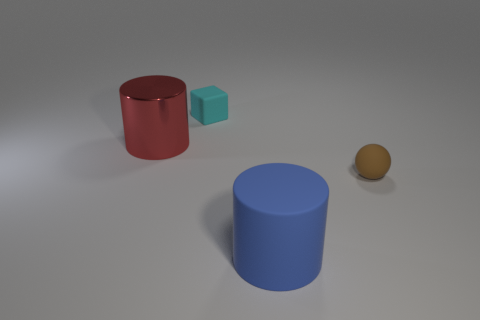What number of blue cylinders are the same size as the red cylinder?
Offer a terse response. 1. What is the shape of the big object that is in front of the large thing that is behind the large rubber cylinder?
Your answer should be very brief. Cylinder. Are there fewer big metal cylinders than tiny objects?
Offer a very short reply. Yes. What color is the small thing that is in front of the red object?
Offer a terse response. Brown. There is a thing that is both to the left of the large blue matte object and on the right side of the red metallic cylinder; what material is it?
Your response must be concise. Rubber. There is a tiny cyan thing that is made of the same material as the tiny brown object; what shape is it?
Provide a succinct answer. Cube. How many blue matte cylinders are on the right side of the big cylinder that is behind the matte ball?
Provide a short and direct response. 1. How many objects are both on the left side of the blue object and in front of the small cube?
Your answer should be very brief. 1. What number of other objects are there of the same material as the tiny sphere?
Offer a terse response. 2. What is the color of the small rubber cube right of the large cylinder to the left of the blue cylinder?
Your answer should be very brief. Cyan. 